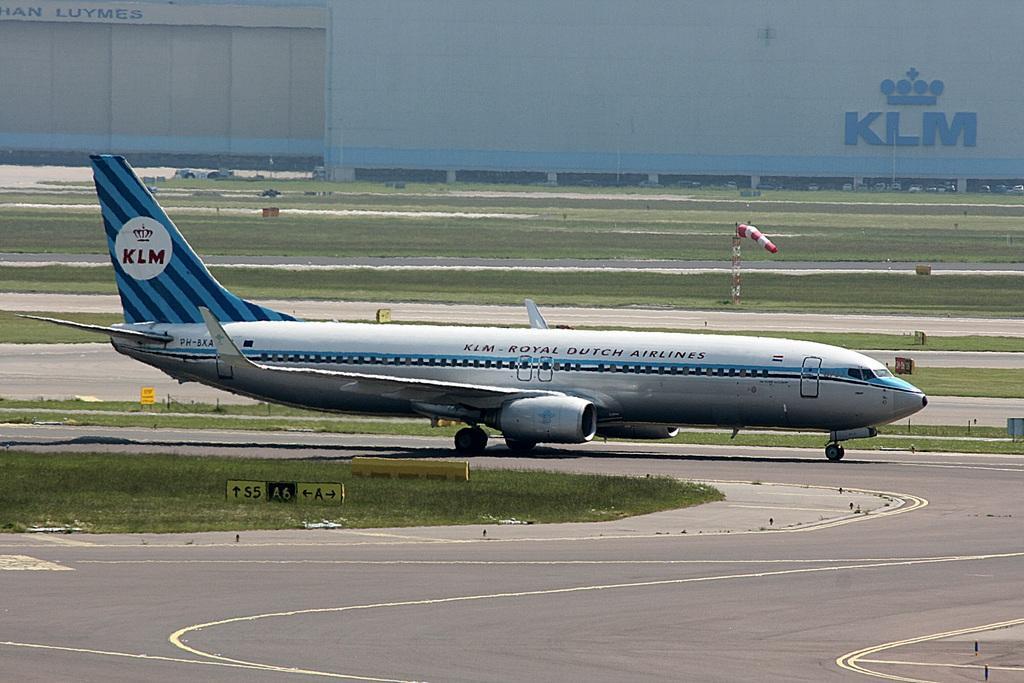Could you give a brief overview of what you see in this image? This is an airplane, which is on the runway. This looks like a board. Here is the grass. I think this is a tower with a cloth hanging. I think this is a building with the names on it. 